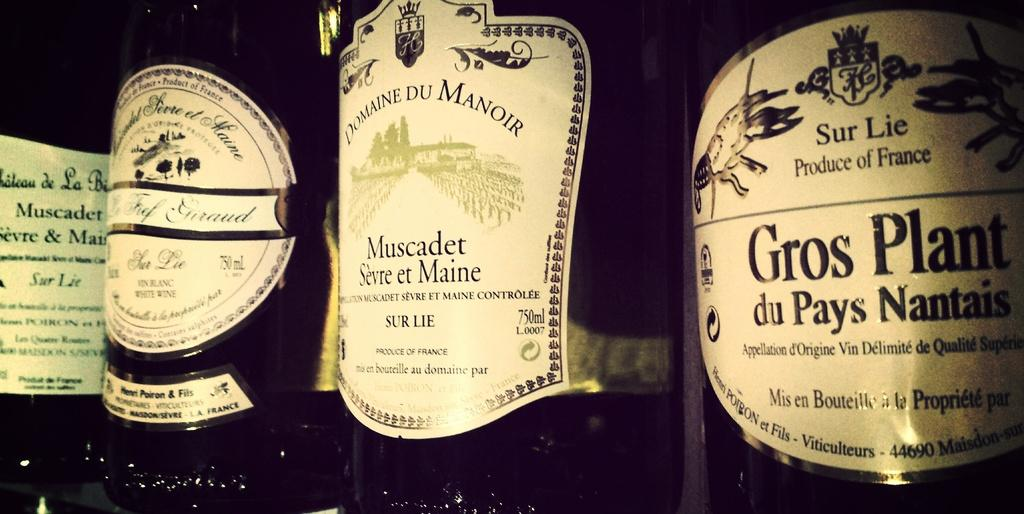Provide a one-sentence caption for the provided image. four bottles of wine, one of which is Gros Plant. 